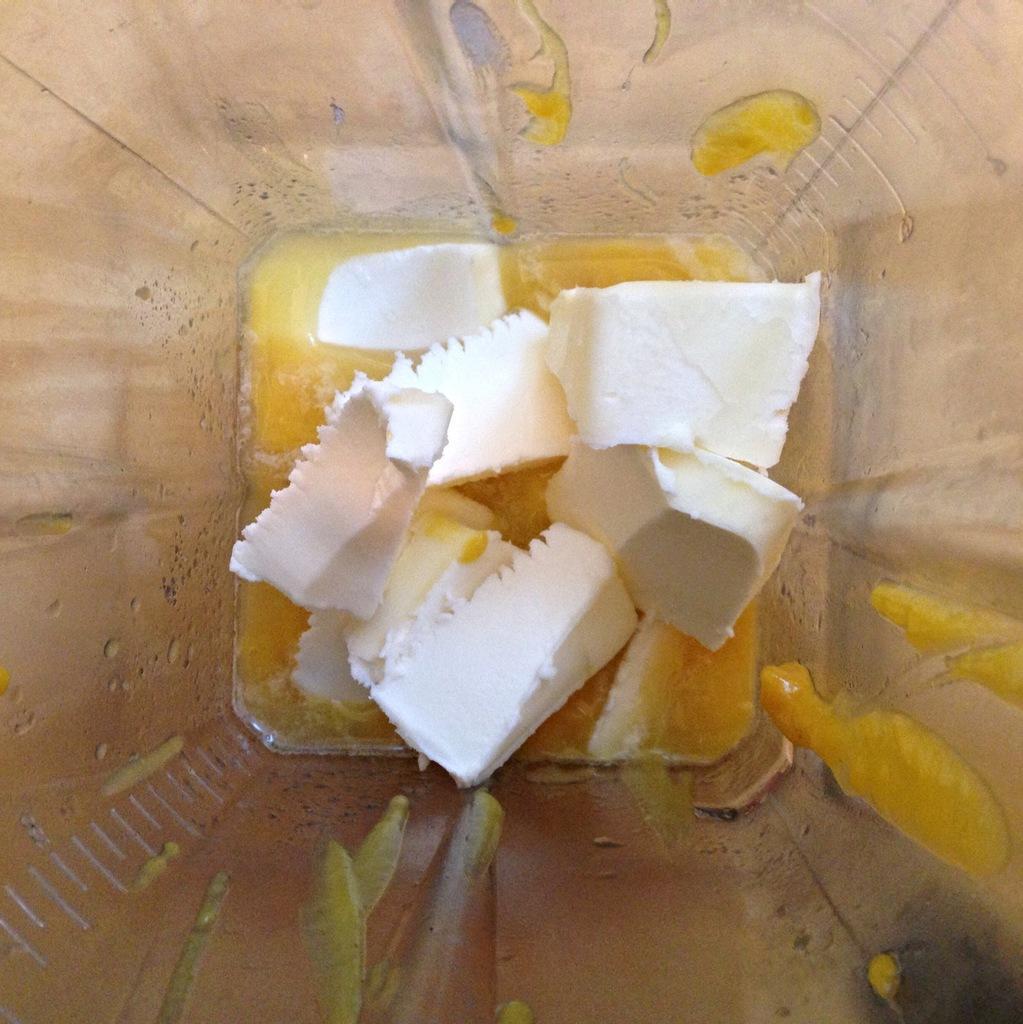In one or two sentences, can you explain what this image depicts? In this image I can see a plastic container in which I can see a yellow colored liquid and few white colored objects. I can see the cream colored surface through the container. 